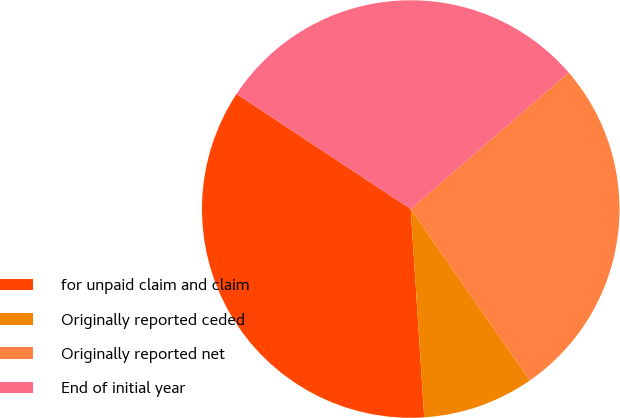<chart> <loc_0><loc_0><loc_500><loc_500><pie_chart><fcel>for unpaid claim and claim<fcel>Originally reported ceded<fcel>Originally reported net<fcel>End of initial year<nl><fcel>35.32%<fcel>8.63%<fcel>26.69%<fcel>29.36%<nl></chart> 